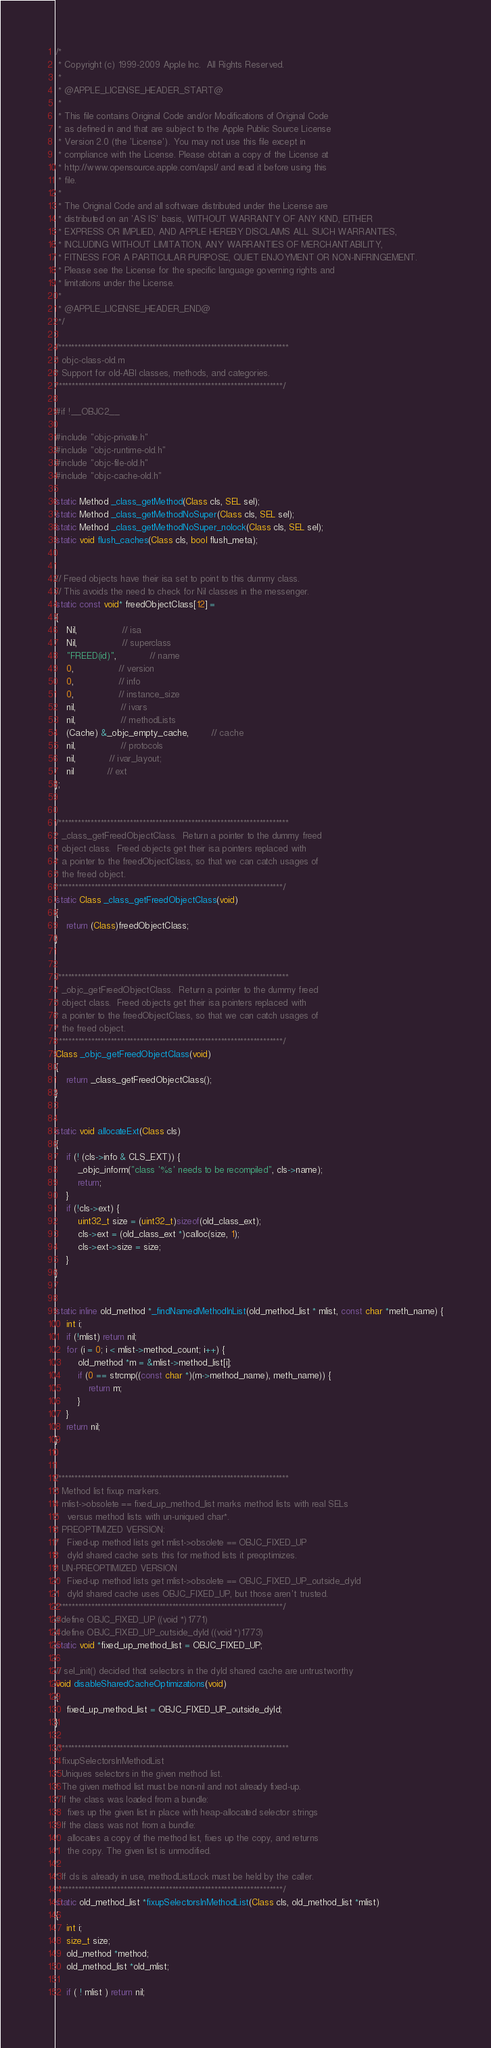Convert code to text. <code><loc_0><loc_0><loc_500><loc_500><_ObjectiveC_>/*
 * Copyright (c) 1999-2009 Apple Inc.  All Rights Reserved.
 * 
 * @APPLE_LICENSE_HEADER_START@
 * 
 * This file contains Original Code and/or Modifications of Original Code
 * as defined in and that are subject to the Apple Public Source License
 * Version 2.0 (the 'License'). You may not use this file except in
 * compliance with the License. Please obtain a copy of the License at
 * http://www.opensource.apple.com/apsl/ and read it before using this
 * file.
 * 
 * The Original Code and all software distributed under the License are
 * distributed on an 'AS IS' basis, WITHOUT WARRANTY OF ANY KIND, EITHER
 * EXPRESS OR IMPLIED, AND APPLE HEREBY DISCLAIMS ALL SUCH WARRANTIES,
 * INCLUDING WITHOUT LIMITATION, ANY WARRANTIES OF MERCHANTABILITY,
 * FITNESS FOR A PARTICULAR PURPOSE, QUIET ENJOYMENT OR NON-INFRINGEMENT.
 * Please see the License for the specific language governing rights and
 * limitations under the License.
 * 
 * @APPLE_LICENSE_HEADER_END@
 */

/***********************************************************************
* objc-class-old.m
* Support for old-ABI classes, methods, and categories.
**********************************************************************/

#if !__OBJC2__

#include "objc-private.h"
#include "objc-runtime-old.h"
#include "objc-file-old.h"
#include "objc-cache-old.h"

static Method _class_getMethod(Class cls, SEL sel);
static Method _class_getMethodNoSuper(Class cls, SEL sel);
static Method _class_getMethodNoSuper_nolock(Class cls, SEL sel);
static void flush_caches(Class cls, bool flush_meta);


// Freed objects have their isa set to point to this dummy class.
// This avoids the need to check for Nil classes in the messenger.
static const void* freedObjectClass[12] =
{
    Nil,				// isa
    Nil,				// superclass
    "FREED(id)",			// name
    0,				// version
    0,				// info
    0,				// instance_size
    nil,				// ivars
    nil,				// methodLists
    (Cache) &_objc_empty_cache,		// cache
    nil,				// protocols
    nil,			// ivar_layout;
    nil			// ext
};


/***********************************************************************
* _class_getFreedObjectClass.  Return a pointer to the dummy freed
* object class.  Freed objects get their isa pointers replaced with
* a pointer to the freedObjectClass, so that we can catch usages of
* the freed object.
**********************************************************************/
static Class _class_getFreedObjectClass(void)
{
    return (Class)freedObjectClass;
}


/***********************************************************************
* _objc_getFreedObjectClass.  Return a pointer to the dummy freed
* object class.  Freed objects get their isa pointers replaced with
* a pointer to the freedObjectClass, so that we can catch usages of
* the freed object.
**********************************************************************/
Class _objc_getFreedObjectClass(void)
{
    return _class_getFreedObjectClass();
}


static void allocateExt(Class cls)
{
    if (! (cls->info & CLS_EXT)) {
        _objc_inform("class '%s' needs to be recompiled", cls->name);
        return;
    } 
    if (!cls->ext) {
        uint32_t size = (uint32_t)sizeof(old_class_ext);
        cls->ext = (old_class_ext *)calloc(size, 1);
        cls->ext->size = size;
    }
}


static inline old_method *_findNamedMethodInList(old_method_list * mlist, const char *meth_name) {
    int i;
    if (!mlist) return nil;
    for (i = 0; i < mlist->method_count; i++) {
        old_method *m = &mlist->method_list[i];
        if (0 == strcmp((const char *)(m->method_name), meth_name)) {
            return m;
        }
    }
    return nil;
}


/***********************************************************************
* Method list fixup markers.
* mlist->obsolete == fixed_up_method_list marks method lists with real SELs 
*   versus method lists with un-uniqued char*.
* PREOPTIMIZED VERSION:
*   Fixed-up method lists get mlist->obsolete == OBJC_FIXED_UP 
*   dyld shared cache sets this for method lists it preoptimizes.
* UN-PREOPTIMIZED VERSION
*   Fixed-up method lists get mlist->obsolete == OBJC_FIXED_UP_outside_dyld
*   dyld shared cache uses OBJC_FIXED_UP, but those aren't trusted.
**********************************************************************/
#define OBJC_FIXED_UP ((void *)1771)
#define OBJC_FIXED_UP_outside_dyld ((void *)1773)
static void *fixed_up_method_list = OBJC_FIXED_UP;

// sel_init() decided that selectors in the dyld shared cache are untrustworthy
void disableSharedCacheOptimizations(void)
{
    fixed_up_method_list = OBJC_FIXED_UP_outside_dyld;
}

/***********************************************************************
* fixupSelectorsInMethodList
* Uniques selectors in the given method list.
* The given method list must be non-nil and not already fixed-up.
* If the class was loaded from a bundle:
*   fixes up the given list in place with heap-allocated selector strings
* If the class was not from a bundle:
*   allocates a copy of the method list, fixes up the copy, and returns 
*   the copy. The given list is unmodified.
*
* If cls is already in use, methodListLock must be held by the caller.
**********************************************************************/
static old_method_list *fixupSelectorsInMethodList(Class cls, old_method_list *mlist)
{
    int i;
    size_t size;
    old_method *method;
    old_method_list *old_mlist; 
    
    if ( ! mlist ) return nil;</code> 